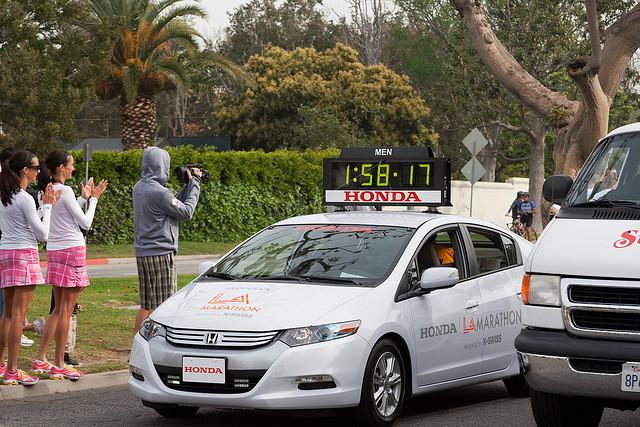What time does the clock say?
Keep it brief. 1:58. How many motorcycles are in the picture?
Be succinct. 0. What is the time?
Write a very short answer. 1:58. What color plaid are the skirts?
Short answer required. Pink. Is this a normal taxi?
Short answer required. No. What letter is on the front of the car?
Quick response, please. La. What event are they cheering for?
Short answer required. Marathon. 